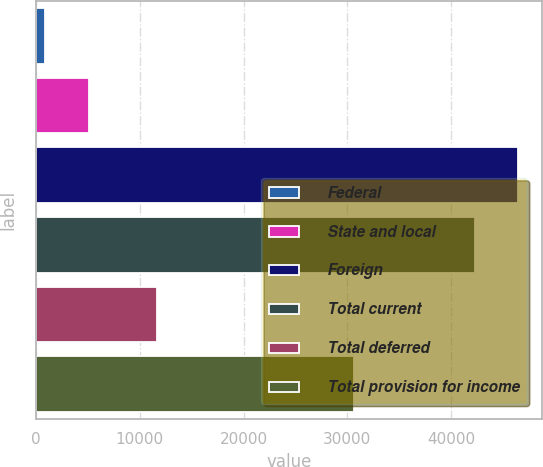Convert chart to OTSL. <chart><loc_0><loc_0><loc_500><loc_500><bar_chart><fcel>Federal<fcel>State and local<fcel>Foreign<fcel>Total current<fcel>Total deferred<fcel>Total provision for income<nl><fcel>902<fcel>5077.5<fcel>46464.5<fcel>42289<fcel>11676<fcel>30613<nl></chart> 